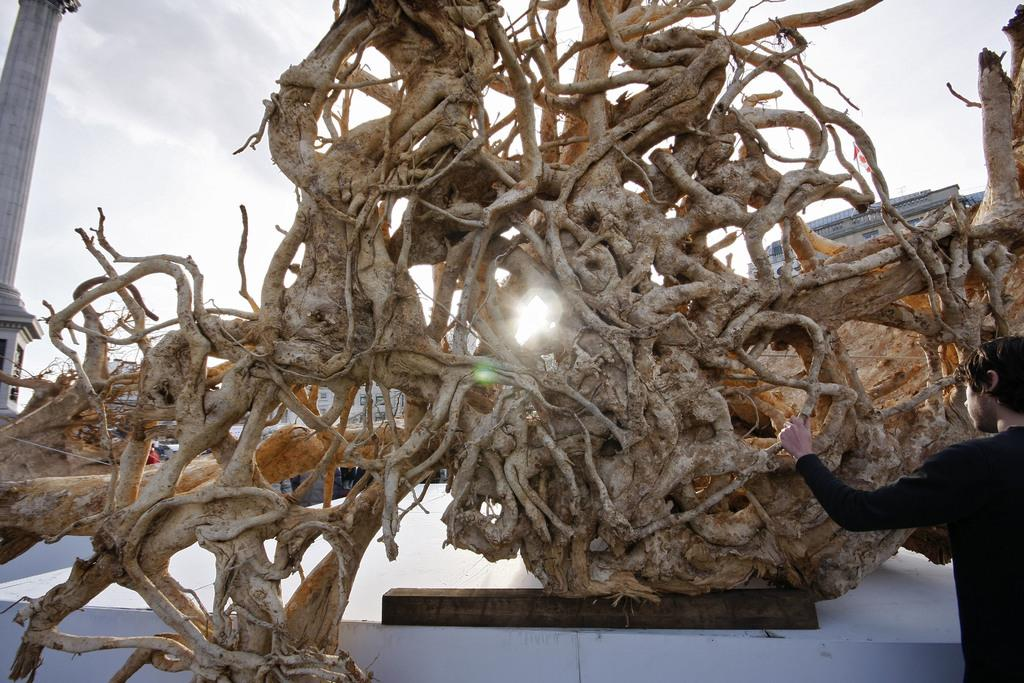What is the main object in the picture? There is a tree in the picture. What is the condition of the tree? The tree has no leaves. What can be seen on the left side of the picture? There is a person standing and a pillar on the left side of the picture. How would you describe the sky in the image? The sky is clear in the picture. What type of spoon is being used to attempt to print the tree in the image? There is no spoon or attempt to print the tree in the image; it is a photograph of a tree without leaves. 